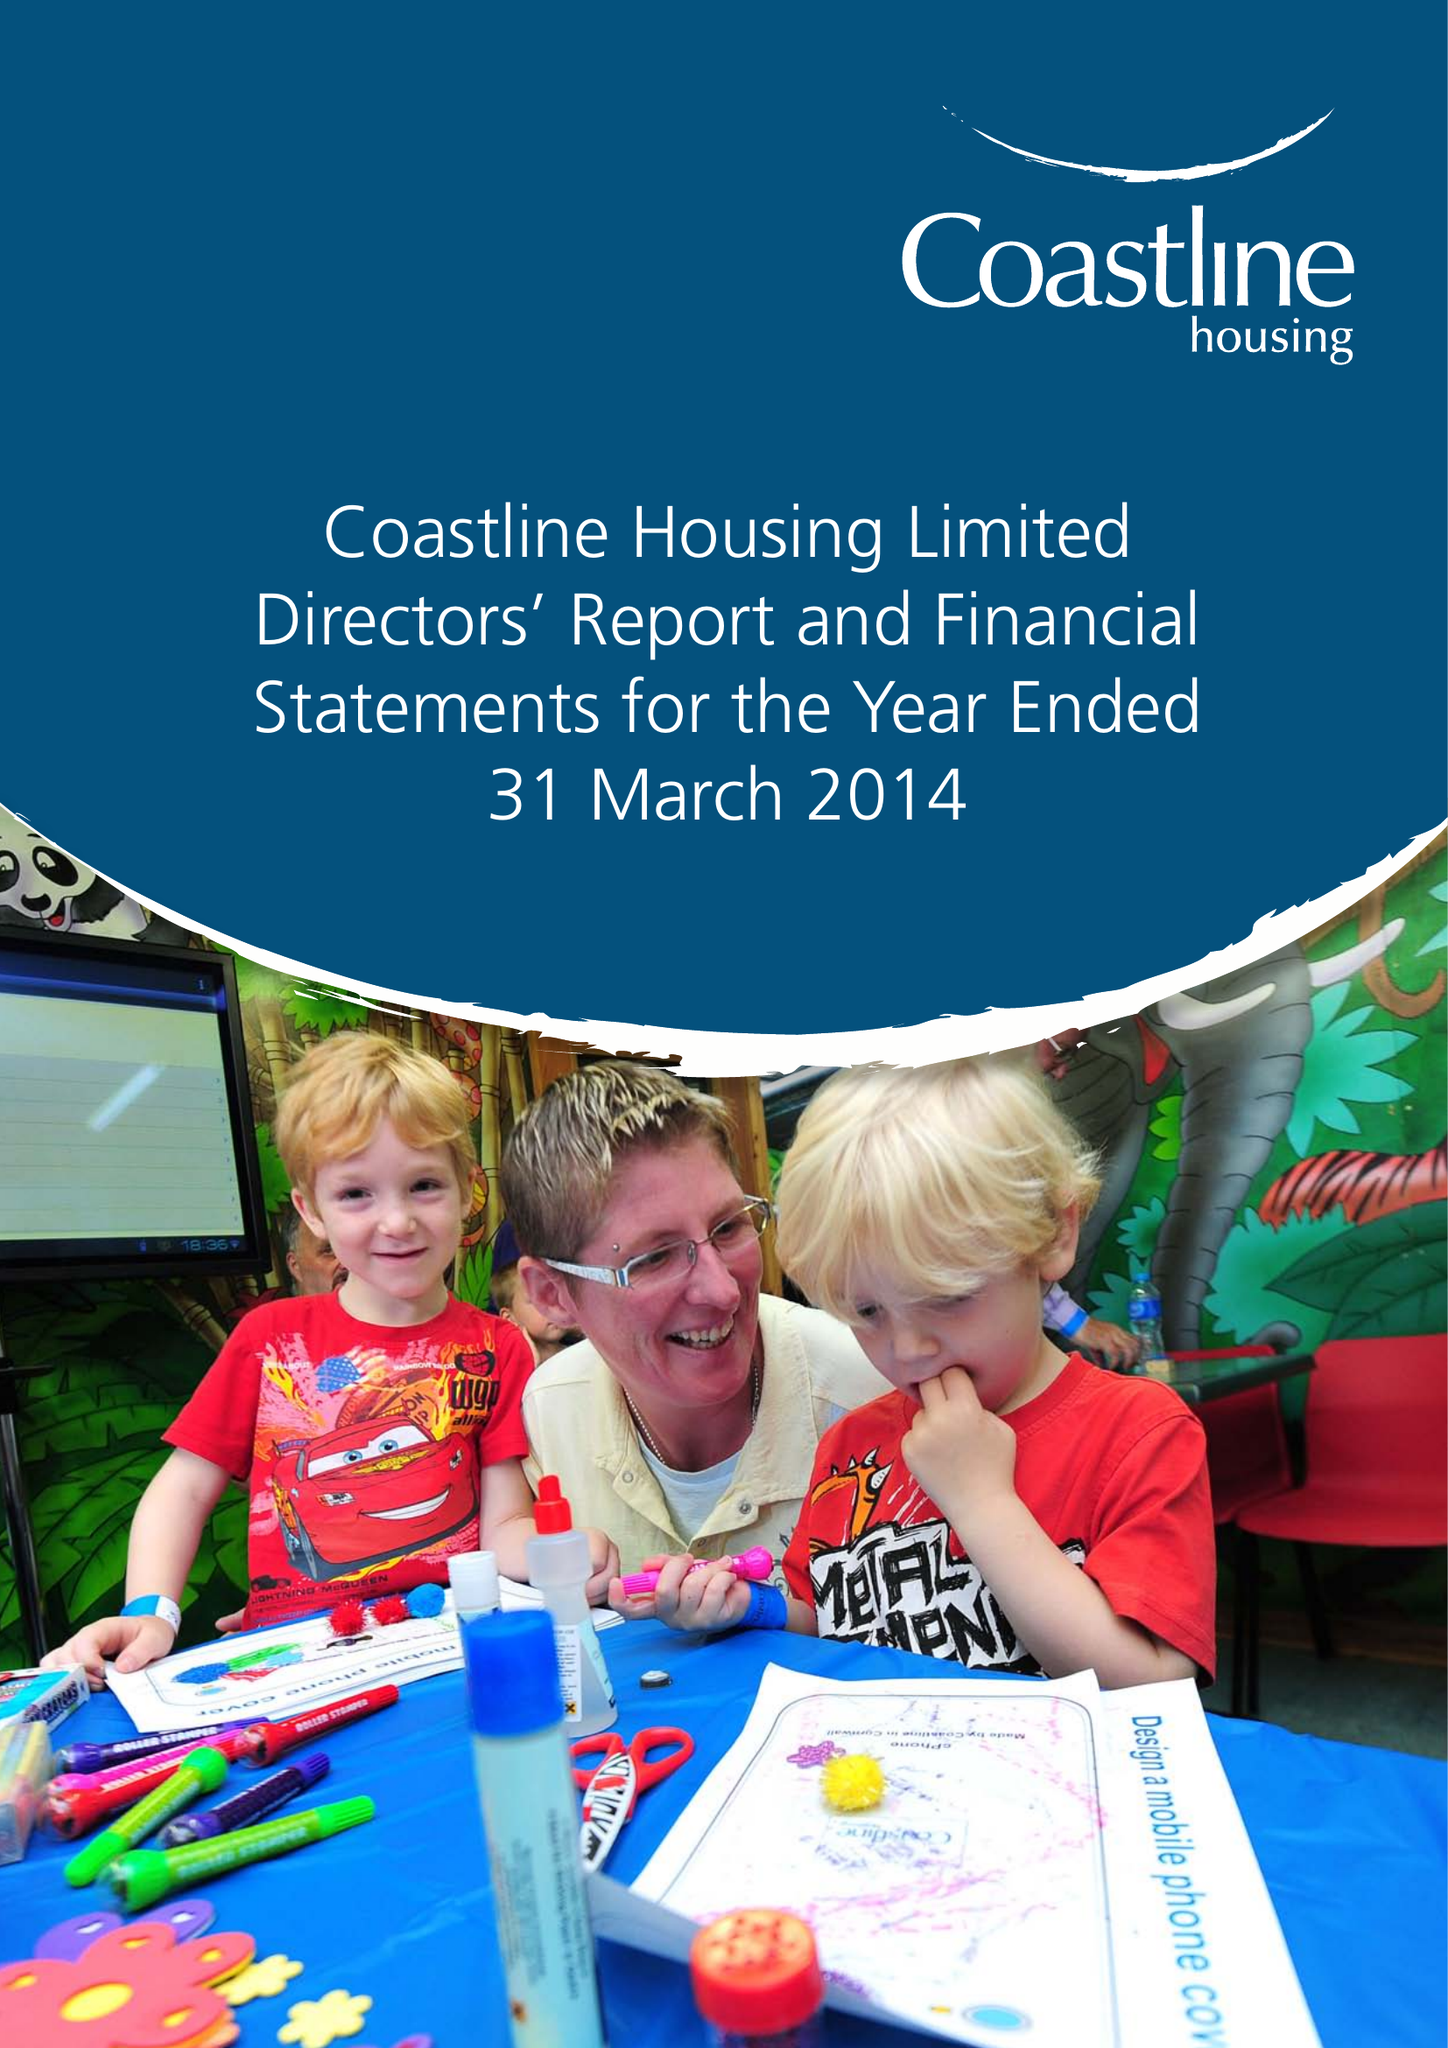What is the value for the income_annually_in_british_pounds?
Answer the question using a single word or phrase. 21983000.00 